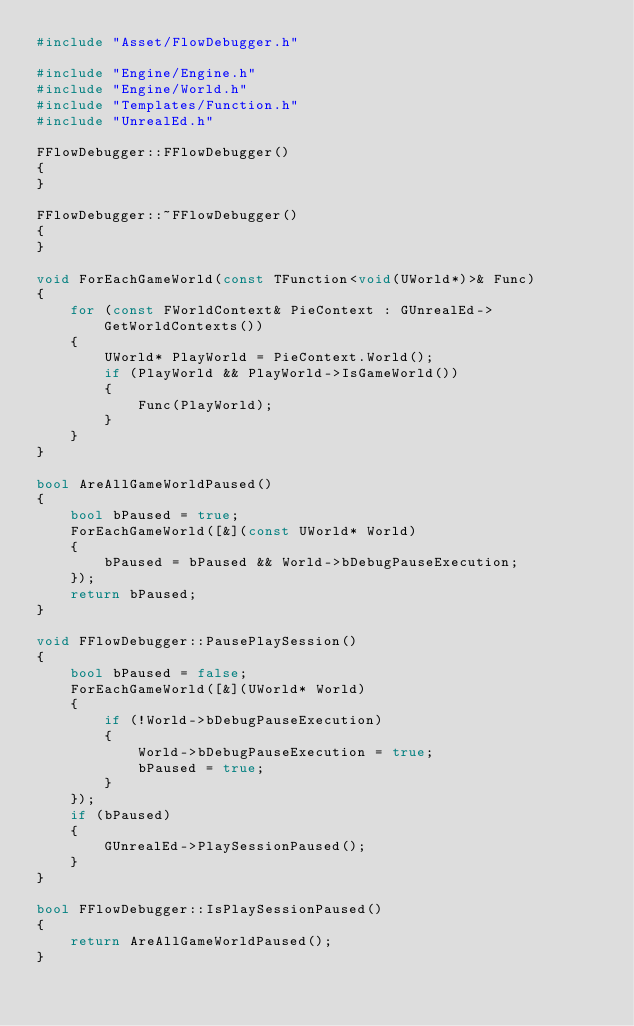Convert code to text. <code><loc_0><loc_0><loc_500><loc_500><_C++_>#include "Asset/FlowDebugger.h"

#include "Engine/Engine.h"
#include "Engine/World.h"
#include "Templates/Function.h"
#include "UnrealEd.h"

FFlowDebugger::FFlowDebugger()
{
}

FFlowDebugger::~FFlowDebugger()
{
}

void ForEachGameWorld(const TFunction<void(UWorld*)>& Func)
{
	for (const FWorldContext& PieContext : GUnrealEd->GetWorldContexts())
	{
		UWorld* PlayWorld = PieContext.World();
		if (PlayWorld && PlayWorld->IsGameWorld())
		{
			Func(PlayWorld);
		}
	}
}

bool AreAllGameWorldPaused()
{
	bool bPaused = true;
	ForEachGameWorld([&](const UWorld* World)
	{
		bPaused = bPaused && World->bDebugPauseExecution;
	});
	return bPaused;
}

void FFlowDebugger::PausePlaySession()
{
	bool bPaused = false;
	ForEachGameWorld([&](UWorld* World)
	{
		if (!World->bDebugPauseExecution)
		{
			World->bDebugPauseExecution = true;
			bPaused = true;
		}
	});
	if (bPaused)
	{
		GUnrealEd->PlaySessionPaused();
	}
}

bool FFlowDebugger::IsPlaySessionPaused()
{
	return AreAllGameWorldPaused();
}
</code> 